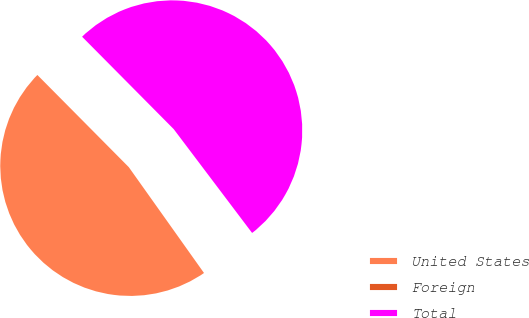Convert chart to OTSL. <chart><loc_0><loc_0><loc_500><loc_500><pie_chart><fcel>United States<fcel>Foreign<fcel>Total<nl><fcel>47.4%<fcel>0.46%<fcel>52.14%<nl></chart> 